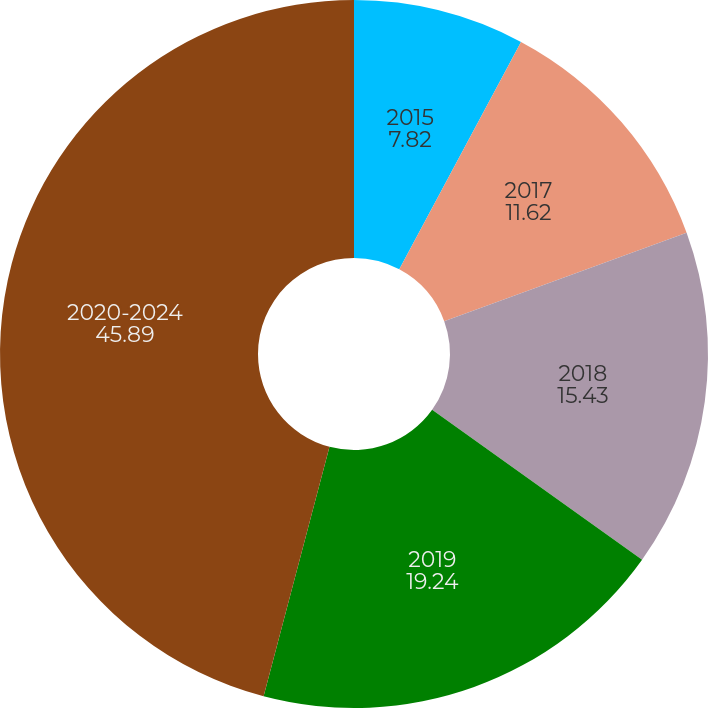<chart> <loc_0><loc_0><loc_500><loc_500><pie_chart><fcel>2015<fcel>2017<fcel>2018<fcel>2019<fcel>2020-2024<nl><fcel>7.82%<fcel>11.62%<fcel>15.43%<fcel>19.24%<fcel>45.89%<nl></chart> 